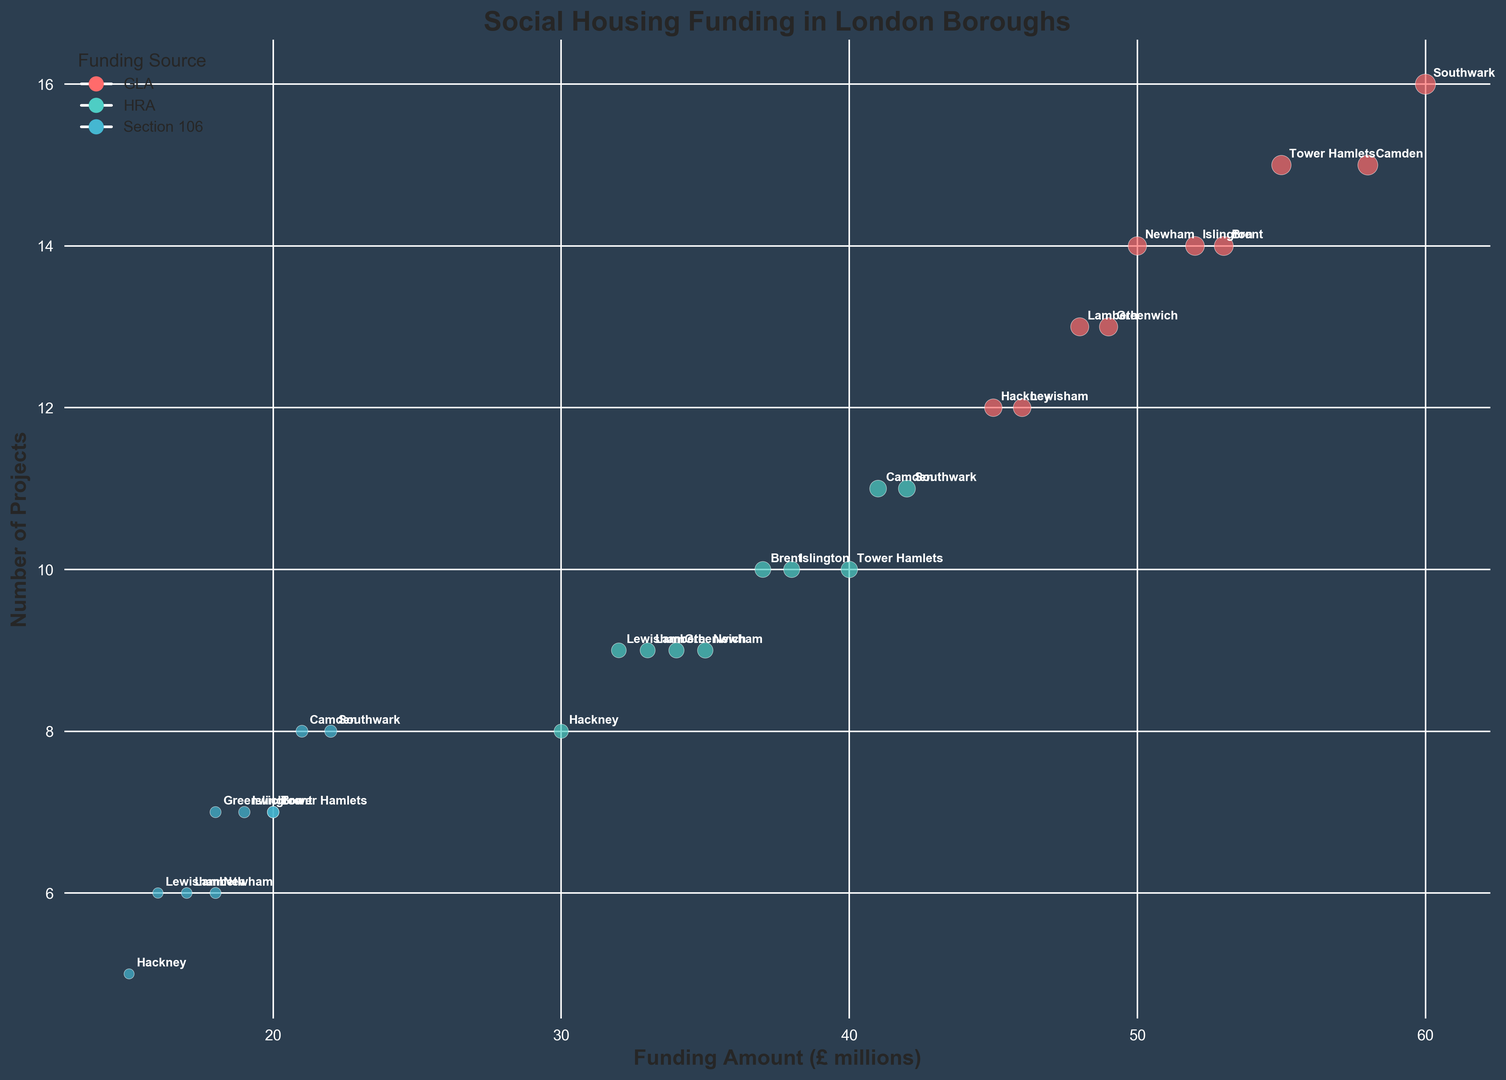Which borough has the highest funding amount from GLA? To determine which borough has the highest funding amount from GLA, look only at the funding sources labeled "GLA" and identify the borough with the largest funding amount.
Answer: Southwark What is the total number of projects funded by Section 106 in Hackney and Tower Hamlets? Add the number of projects funded by Section 106 in Hackney (5) to the number in Tower Hamlets (7).
Answer: 12 How does the amount of funding from HRA in Newham compare to that in Islington? Compare the funding amounts from HRA in Newham (35 million) and Islington (38 million).
Answer: Islington has more HRA funding than Newham Which funding source has the smallest bubble in Camden and what is the funding amount for that source? Look at the sizes of the bubbles in Camden and identify the smallest. The smallest bubble corresponds to the Section 106 funding amount which is 21 million.
Answer: Section 106, 21 million What's the average funding amount from GLA across all boroughs? Sum the GLA funding amounts for all boroughs and then divide by the number of boroughs. (45 + 55 + 50 + 60 + 48 + 52 + 58 + 46 + 49 + 53) / 10 = 516 / 10
Answer: 51.6 million Between Hackney and Lambeth, which has a higher number of projects funded by HRA? Compare the number of projects funded by HRA in Hackney (8) and Lambeth (9).
Answer: Lambeth What funding source has the largest number of projects in Southwark? Look at all the bubbles for Southwark and identify the one with the highest number of projects. The one with the highest number of projects is GLA with 16 projects.
Answer: GLA How many more projects does Tower Hamlets have funded by GLA compared to Section 106? Subtract the number of projects funded by Section 106 in Tower Hamlets (7) from the number funded by GLA (15): 15 - 7.
Answer: 8 Which borough has more funding, Newham or Brent, and by how much? Sum all the funding sources for both Newham (50 + 35 + 18 = 103 million) and Brent (53 + 37 + 20 = 110 million), and subtract Newham's total from Brent's total.
Answer: Brent by 7 million Which bubble color represents Section 106 funding, and which borough has the largest number of projects for this funding source? Identify the color used for Section 106 funding and see which borough has the largest number of projects associated with that color. The color for Section 106 funding is blue and Southwark has the largest number of projects, which is 8.
Answer: Blue, Southwark 